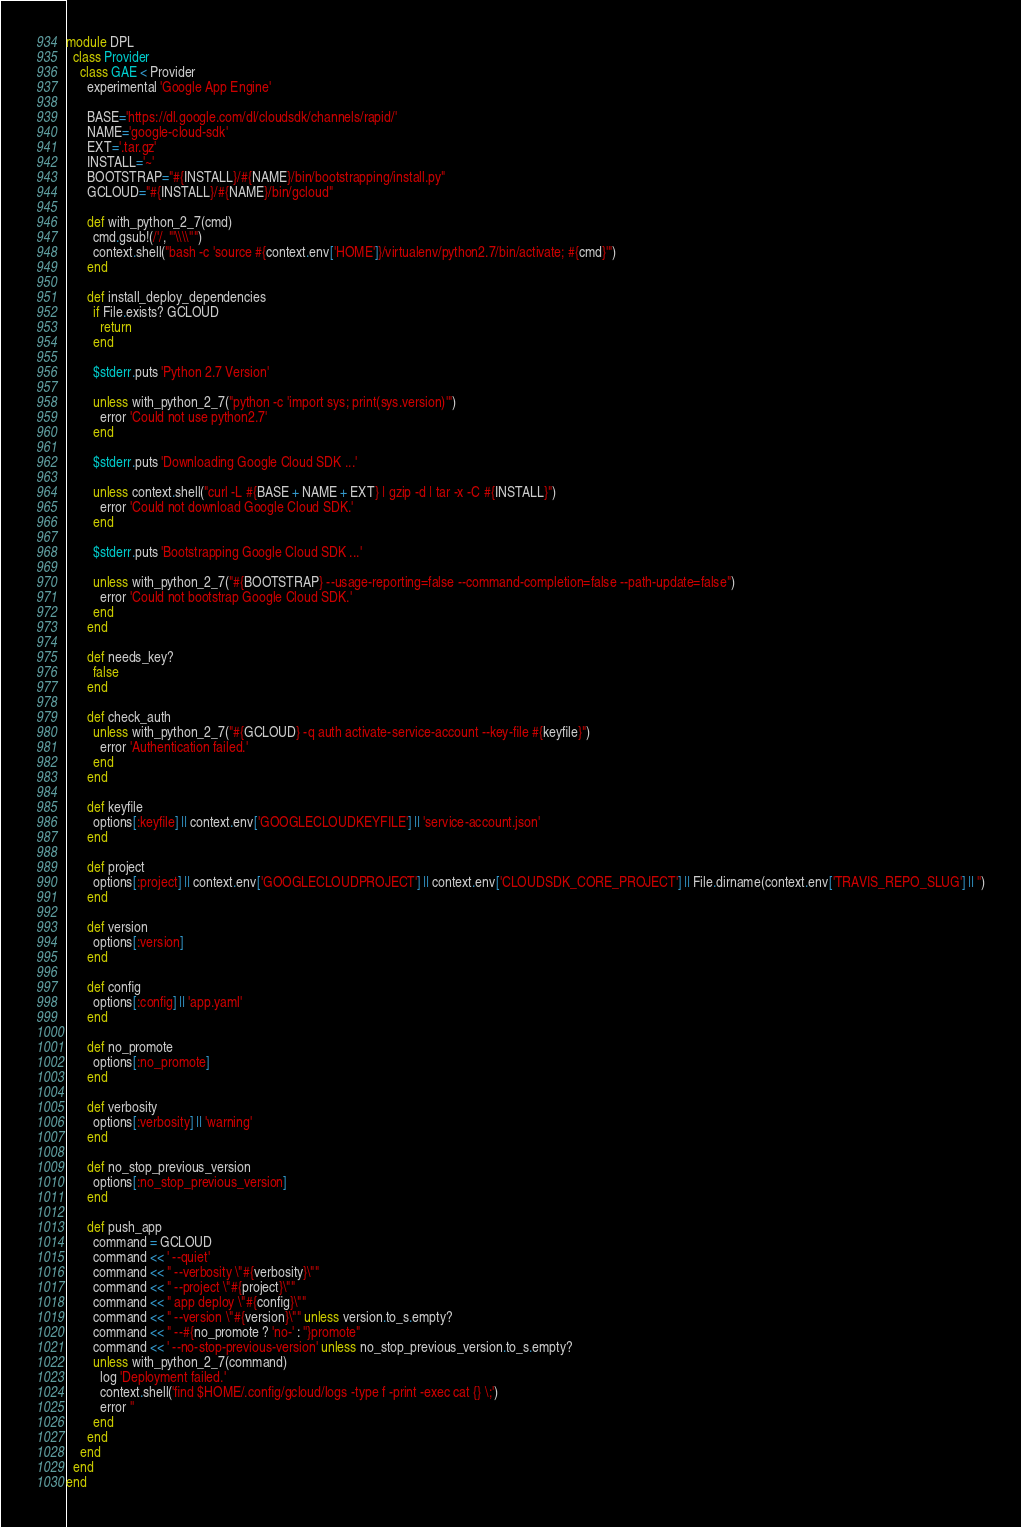<code> <loc_0><loc_0><loc_500><loc_500><_Ruby_>module DPL
  class Provider
    class GAE < Provider
      experimental 'Google App Engine'

      BASE='https://dl.google.com/dl/cloudsdk/channels/rapid/'
      NAME='google-cloud-sdk'
      EXT='.tar.gz'
      INSTALL='~'
      BOOTSTRAP="#{INSTALL}/#{NAME}/bin/bootstrapping/install.py"
      GCLOUD="#{INSTALL}/#{NAME}/bin/gcloud"

      def with_python_2_7(cmd)
        cmd.gsub!(/'/, "'\\\\''")
        context.shell("bash -c 'source #{context.env['HOME']}/virtualenv/python2.7/bin/activate; #{cmd}'")
      end

      def install_deploy_dependencies
        if File.exists? GCLOUD
          return
        end

        $stderr.puts 'Python 2.7 Version'

        unless with_python_2_7("python -c 'import sys; print(sys.version)'")
          error 'Could not use python2.7'
        end

        $stderr.puts 'Downloading Google Cloud SDK ...'

        unless context.shell("curl -L #{BASE + NAME + EXT} | gzip -d | tar -x -C #{INSTALL}")
          error 'Could not download Google Cloud SDK.'
        end

        $stderr.puts 'Bootstrapping Google Cloud SDK ...'

        unless with_python_2_7("#{BOOTSTRAP} --usage-reporting=false --command-completion=false --path-update=false")
          error 'Could not bootstrap Google Cloud SDK.'
        end
      end

      def needs_key?
        false
      end

      def check_auth
        unless with_python_2_7("#{GCLOUD} -q auth activate-service-account --key-file #{keyfile}")
          error 'Authentication failed.'
        end
      end

      def keyfile
        options[:keyfile] || context.env['GOOGLECLOUDKEYFILE'] || 'service-account.json'
      end

      def project
        options[:project] || context.env['GOOGLECLOUDPROJECT'] || context.env['CLOUDSDK_CORE_PROJECT'] || File.dirname(context.env['TRAVIS_REPO_SLUG'] || '')
      end

      def version
        options[:version]
      end

      def config
        options[:config] || 'app.yaml'
      end

      def no_promote
        options[:no_promote]
      end

      def verbosity
        options[:verbosity] || 'warning'
      end

      def no_stop_previous_version
        options[:no_stop_previous_version]
      end

      def push_app
        command = GCLOUD
        command << ' --quiet'
        command << " --verbosity \"#{verbosity}\""
        command << " --project \"#{project}\""
        command << " app deploy \"#{config}\""
        command << " --version \"#{version}\"" unless version.to_s.empty?
        command << " --#{no_promote ? 'no-' : ''}promote"
        command << ' --no-stop-previous-version' unless no_stop_previous_version.to_s.empty?
        unless with_python_2_7(command)
          log 'Deployment failed.'
          context.shell('find $HOME/.config/gcloud/logs -type f -print -exec cat {} \;')
          error ''
        end
      end
    end
  end
end
</code> 